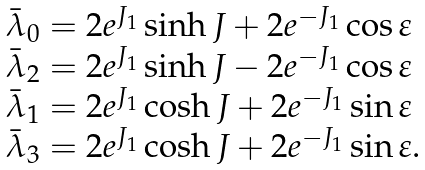Convert formula to latex. <formula><loc_0><loc_0><loc_500><loc_500>\begin{array} { l } \bar { \lambda } _ { 0 } = 2 e ^ { J _ { 1 } } \sinh J + 2 e ^ { - J _ { 1 } } \cos \varepsilon \\ \bar { \lambda } _ { 2 } = 2 e ^ { J _ { 1 } } \sinh J - 2 e ^ { - J _ { 1 } } \cos \varepsilon \\ \bar { \lambda } _ { 1 } = 2 e ^ { J _ { 1 } } \cosh J + 2 e ^ { - J _ { 1 } } \sin \varepsilon \\ \bar { \lambda } _ { 3 } = 2 e ^ { J _ { 1 } } \cosh J + 2 e ^ { - J _ { 1 } } \sin \varepsilon . \end{array}</formula> 